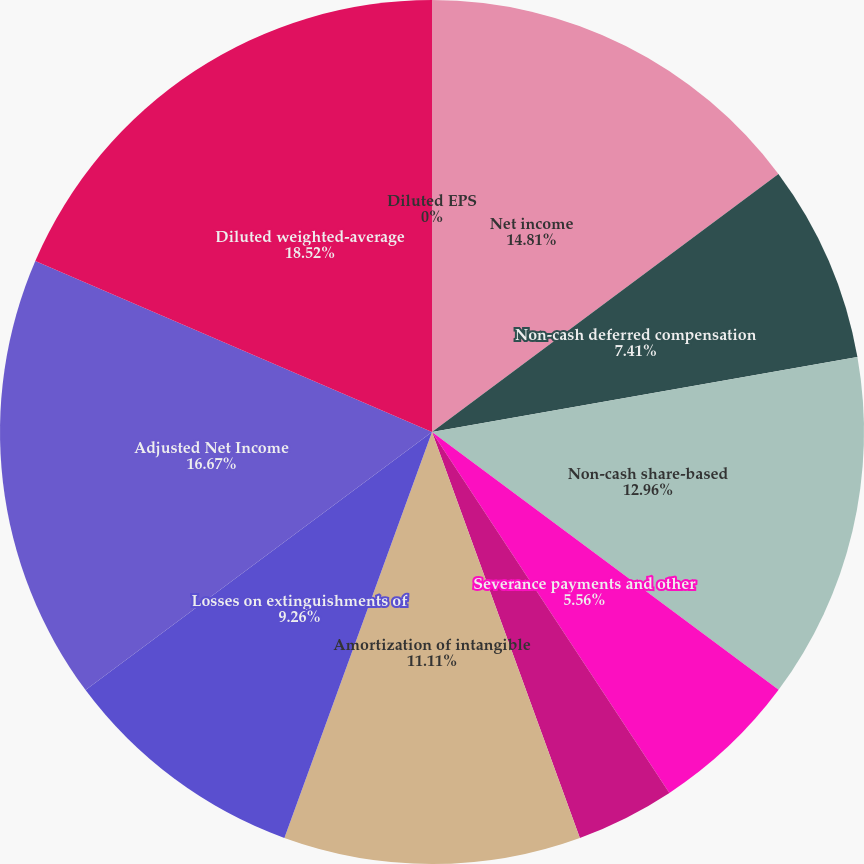<chart> <loc_0><loc_0><loc_500><loc_500><pie_chart><fcel>Net income<fcel>Non-cash deferred compensation<fcel>Non-cash share-based<fcel>Severance payments and other<fcel>Acquisition of Prestige<fcel>Amortization of intangible<fcel>Losses on extinguishments of<fcel>Adjusted Net Income<fcel>Diluted weighted-average<fcel>Diluted EPS<nl><fcel>14.81%<fcel>7.41%<fcel>12.96%<fcel>5.56%<fcel>3.7%<fcel>11.11%<fcel>9.26%<fcel>16.67%<fcel>18.52%<fcel>0.0%<nl></chart> 